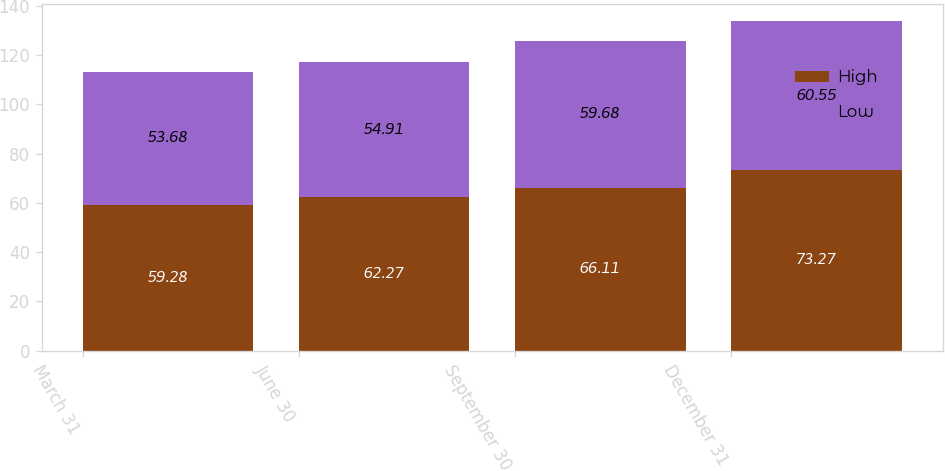<chart> <loc_0><loc_0><loc_500><loc_500><stacked_bar_chart><ecel><fcel>March 31<fcel>June 30<fcel>September 30<fcel>December 31<nl><fcel>High<fcel>59.28<fcel>62.27<fcel>66.11<fcel>73.27<nl><fcel>Low<fcel>53.68<fcel>54.91<fcel>59.68<fcel>60.55<nl></chart> 